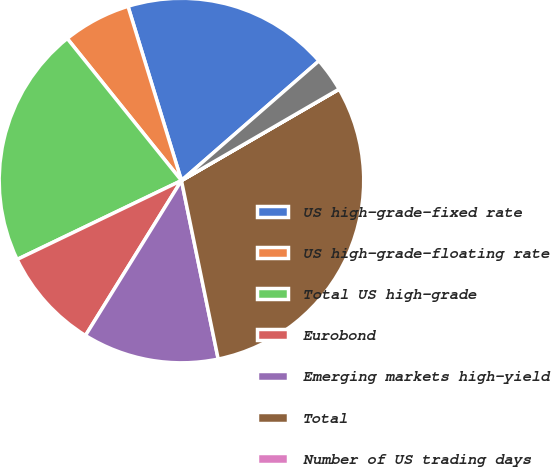<chart> <loc_0><loc_0><loc_500><loc_500><pie_chart><fcel>US high-grade-fixed rate<fcel>US high-grade-floating rate<fcel>Total US high-grade<fcel>Eurobond<fcel>Emerging markets high-yield<fcel>Total<fcel>Number of US trading days<fcel>Number of UK trading days<nl><fcel>18.34%<fcel>6.04%<fcel>21.35%<fcel>9.05%<fcel>12.06%<fcel>30.13%<fcel>0.01%<fcel>3.03%<nl></chart> 